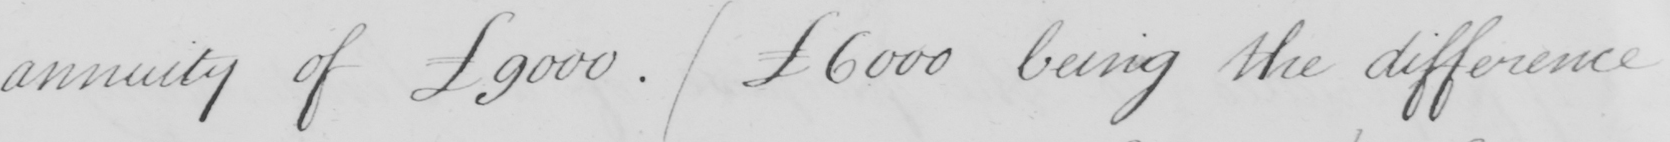Transcribe the text shown in this historical manuscript line. annuity of £9000 .  (  £6000 being the difference 